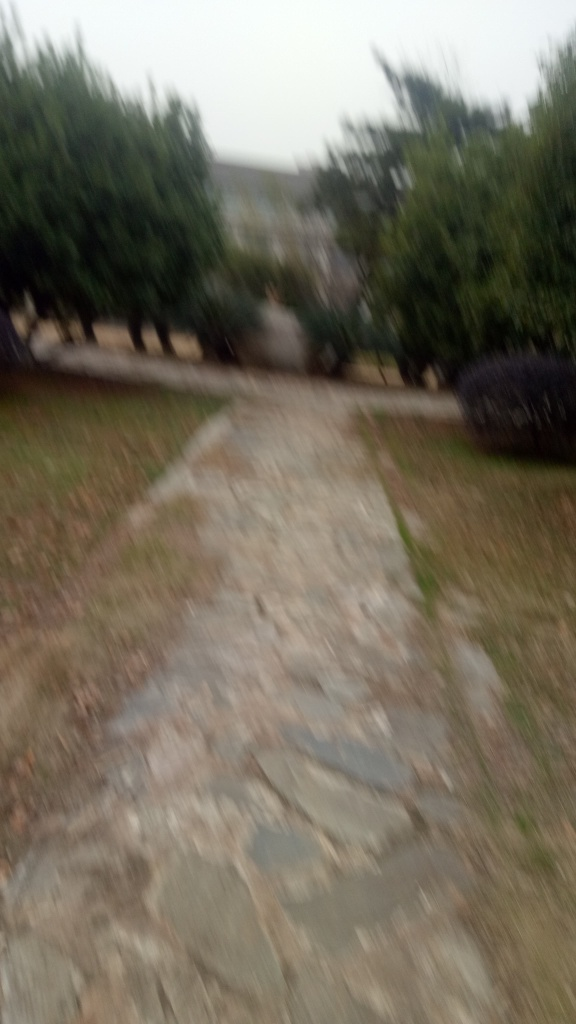Is the exposure well-balanced? The overall exposure of the image appears to be imbalanced due to significant blur and lack of focus, which suggests either a camera shake or a moving subject. A well-balanced exposure would ideally present clear and sharp details across the photo. 